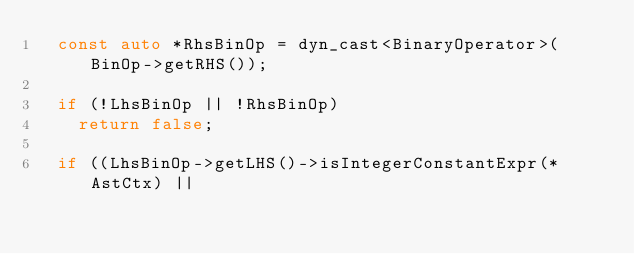<code> <loc_0><loc_0><loc_500><loc_500><_C++_>  const auto *RhsBinOp = dyn_cast<BinaryOperator>(BinOp->getRHS());

  if (!LhsBinOp || !RhsBinOp)
    return false;

  if ((LhsBinOp->getLHS()->isIntegerConstantExpr(*AstCtx) ||</code> 